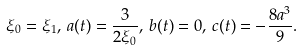Convert formula to latex. <formula><loc_0><loc_0><loc_500><loc_500>\xi _ { 0 } = \xi _ { 1 } , \, a ( t ) = \frac { 3 } { 2 \xi _ { 0 } } , \, b ( t ) = 0 , \, c ( t ) = - \frac { 8 a ^ { 3 } } { 9 } .</formula> 